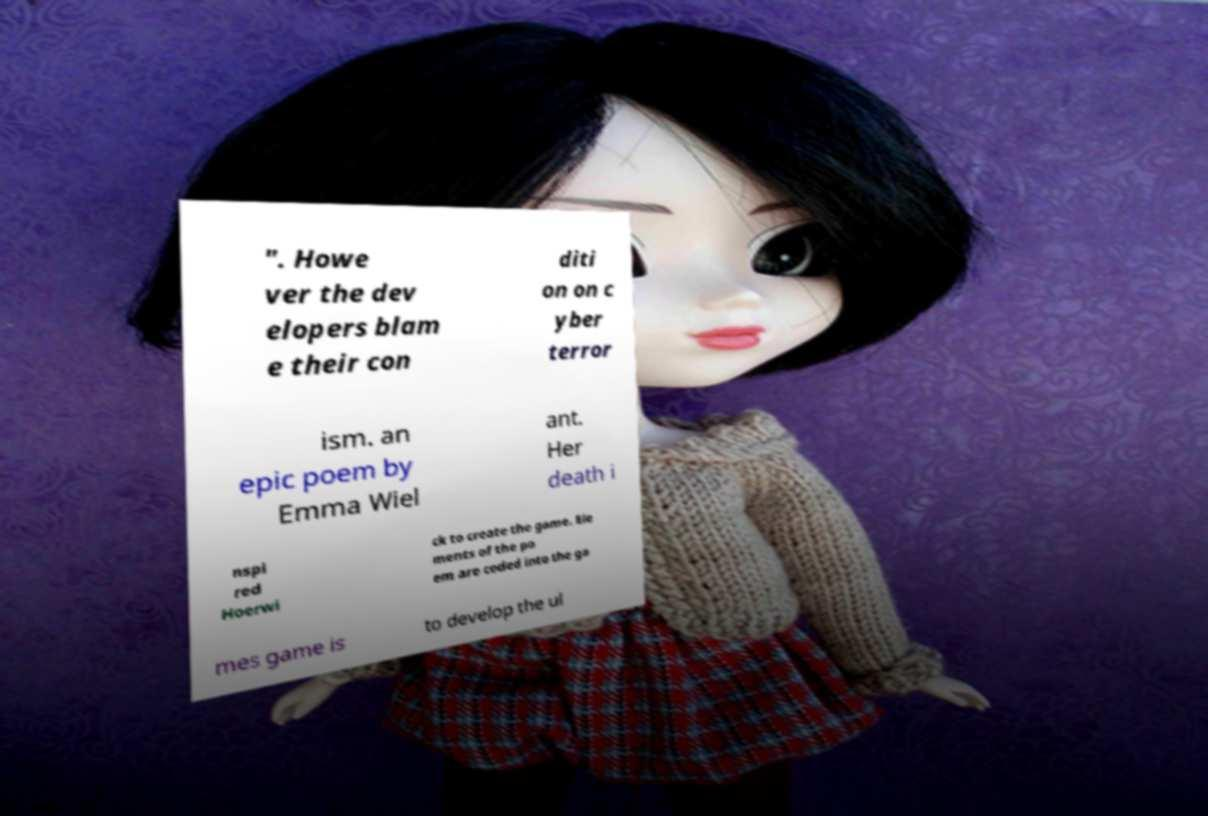There's text embedded in this image that I need extracted. Can you transcribe it verbatim? ". Howe ver the dev elopers blam e their con diti on on c yber terror ism. an epic poem by Emma Wiel ant. Her death i nspi red Hoerwi ck to create the game. Ele ments of the po em are coded into the ga mes game is to develop the ul 